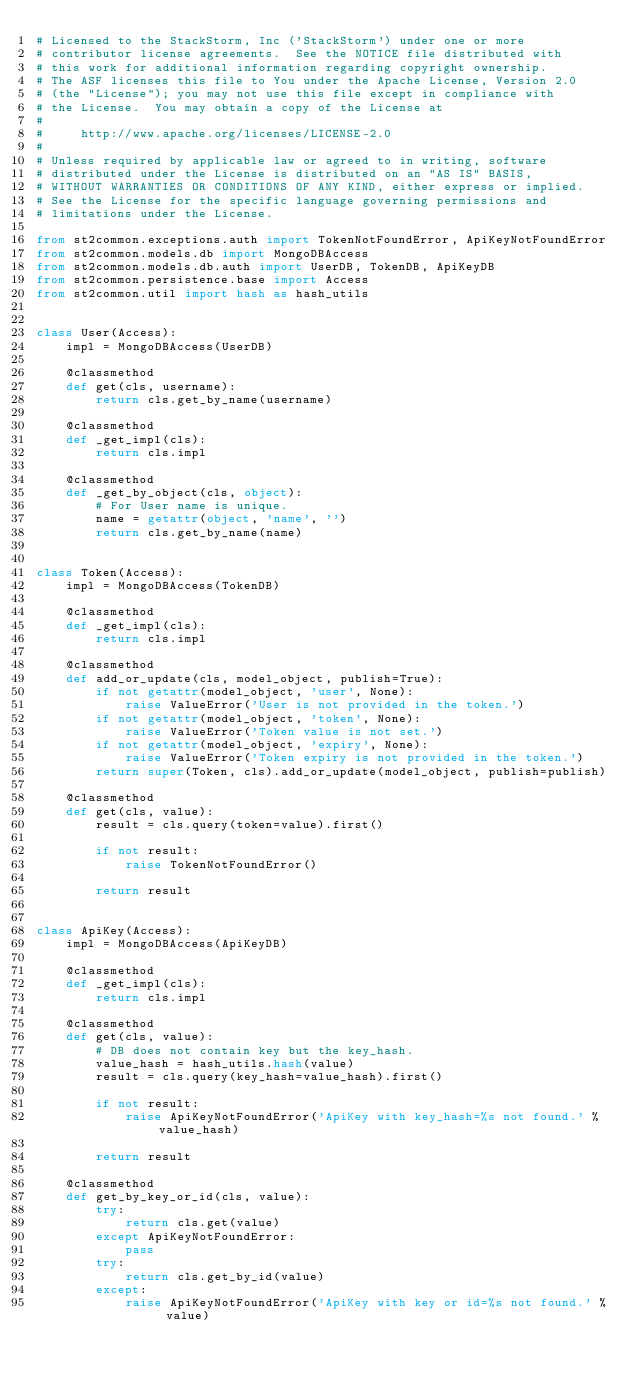<code> <loc_0><loc_0><loc_500><loc_500><_Python_># Licensed to the StackStorm, Inc ('StackStorm') under one or more
# contributor license agreements.  See the NOTICE file distributed with
# this work for additional information regarding copyright ownership.
# The ASF licenses this file to You under the Apache License, Version 2.0
# (the "License"); you may not use this file except in compliance with
# the License.  You may obtain a copy of the License at
#
#     http://www.apache.org/licenses/LICENSE-2.0
#
# Unless required by applicable law or agreed to in writing, software
# distributed under the License is distributed on an "AS IS" BASIS,
# WITHOUT WARRANTIES OR CONDITIONS OF ANY KIND, either express or implied.
# See the License for the specific language governing permissions and
# limitations under the License.

from st2common.exceptions.auth import TokenNotFoundError, ApiKeyNotFoundError
from st2common.models.db import MongoDBAccess
from st2common.models.db.auth import UserDB, TokenDB, ApiKeyDB
from st2common.persistence.base import Access
from st2common.util import hash as hash_utils


class User(Access):
    impl = MongoDBAccess(UserDB)

    @classmethod
    def get(cls, username):
        return cls.get_by_name(username)

    @classmethod
    def _get_impl(cls):
        return cls.impl

    @classmethod
    def _get_by_object(cls, object):
        # For User name is unique.
        name = getattr(object, 'name', '')
        return cls.get_by_name(name)


class Token(Access):
    impl = MongoDBAccess(TokenDB)

    @classmethod
    def _get_impl(cls):
        return cls.impl

    @classmethod
    def add_or_update(cls, model_object, publish=True):
        if not getattr(model_object, 'user', None):
            raise ValueError('User is not provided in the token.')
        if not getattr(model_object, 'token', None):
            raise ValueError('Token value is not set.')
        if not getattr(model_object, 'expiry', None):
            raise ValueError('Token expiry is not provided in the token.')
        return super(Token, cls).add_or_update(model_object, publish=publish)

    @classmethod
    def get(cls, value):
        result = cls.query(token=value).first()

        if not result:
            raise TokenNotFoundError()

        return result


class ApiKey(Access):
    impl = MongoDBAccess(ApiKeyDB)

    @classmethod
    def _get_impl(cls):
        return cls.impl

    @classmethod
    def get(cls, value):
        # DB does not contain key but the key_hash.
        value_hash = hash_utils.hash(value)
        result = cls.query(key_hash=value_hash).first()

        if not result:
            raise ApiKeyNotFoundError('ApiKey with key_hash=%s not found.' % value_hash)

        return result

    @classmethod
    def get_by_key_or_id(cls, value):
        try:
            return cls.get(value)
        except ApiKeyNotFoundError:
            pass
        try:
            return cls.get_by_id(value)
        except:
            raise ApiKeyNotFoundError('ApiKey with key or id=%s not found.' % value)
</code> 